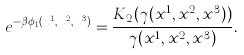Convert formula to latex. <formula><loc_0><loc_0><loc_500><loc_500>e ^ { - \beta \phi _ { 1 } ( x ^ { 1 } , x ^ { 2 } , x ^ { 3 } ) } = \frac { K _ { 2 } ( \gamma ( x ^ { 1 } , x ^ { 2 } , x ^ { 3 } ) ) } { \gamma ( x ^ { 1 } , x ^ { 2 } , x ^ { 3 } ) } .</formula> 